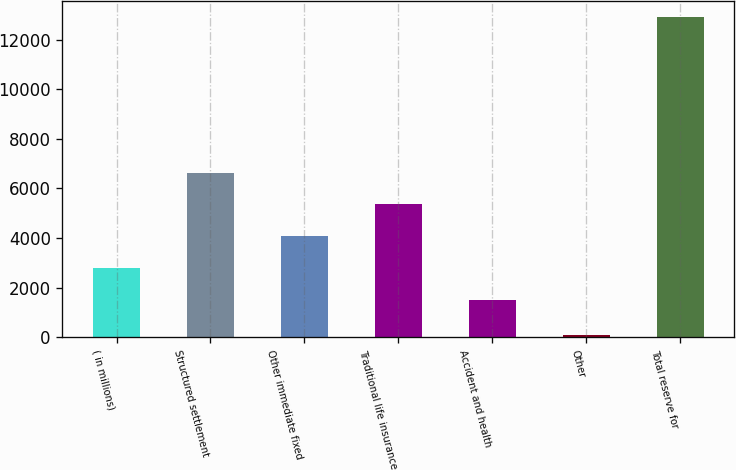Convert chart. <chart><loc_0><loc_0><loc_500><loc_500><bar_chart><fcel>( in millions)<fcel>Structured settlement<fcel>Other immediate fixed<fcel>Traditional life insurance<fcel>Accident and health<fcel>Other<fcel>Total reserve for<nl><fcel>2795.8<fcel>6641.2<fcel>4077.6<fcel>5359.4<fcel>1514<fcel>92<fcel>12910<nl></chart> 